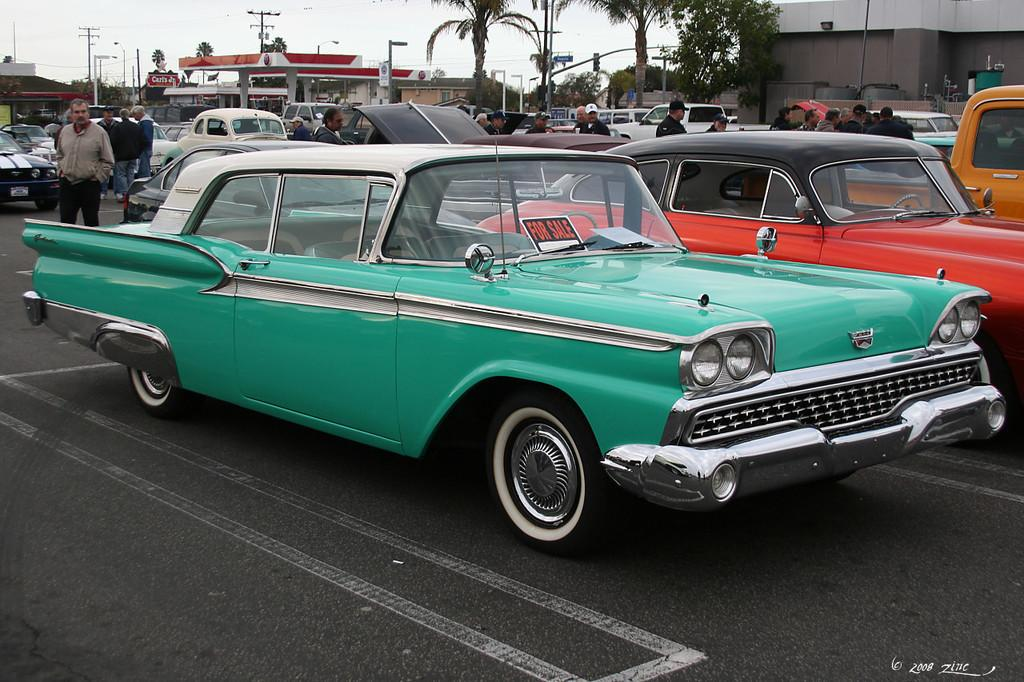What types of objects can be seen in the image? There are vehicles and people in the image. What can be seen in the background of the image? There are buildings, trees, poles, and the sky visible in the background of the image. Can you describe the unspecified objects in the background? Unfortunately, the provided facts do not specify the nature of these unspecified objects. What type of jam is being prepared by the expert in the image? There is no expert or jam preparation visible in the image. How many drops of water can be seen falling from the sky in the image? The sky is visible in the background of the image, but there is no indication of rain or drops of water falling. 